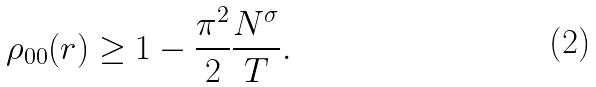Convert formula to latex. <formula><loc_0><loc_0><loc_500><loc_500>\rho _ { 0 0 } ( r ) \geq 1 - \frac { \pi ^ { 2 } } { 2 } \frac { N ^ { \sigma } } { T } .</formula> 